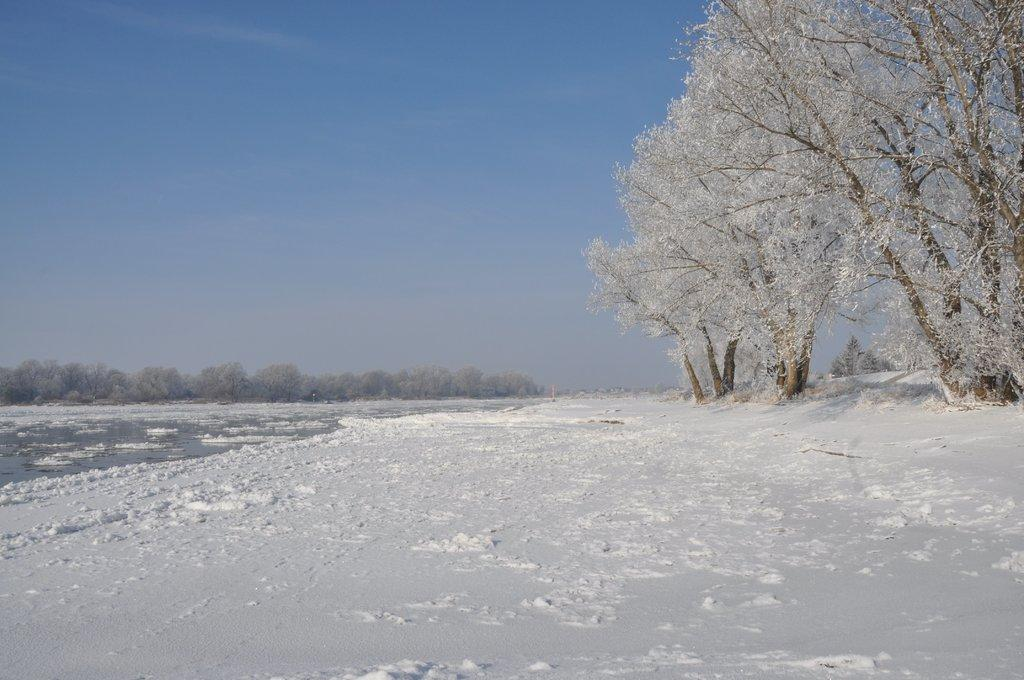What type of vegetation is present in the image? There are many trees in the image. What is covering the ground in the image? There is snow at the bottom of the image. What can be seen in the background of the image? There is water visible in the background of the image. What is visible at the top of the image? The sky is visible at the top of the image. Can you see anyone ploughing the snow in the image? There is no one ploughing the snow in the image; it is just a natural scene with trees, snow, water, and sky. 